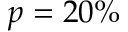Convert formula to latex. <formula><loc_0><loc_0><loc_500><loc_500>p = 2 0 \%</formula> 